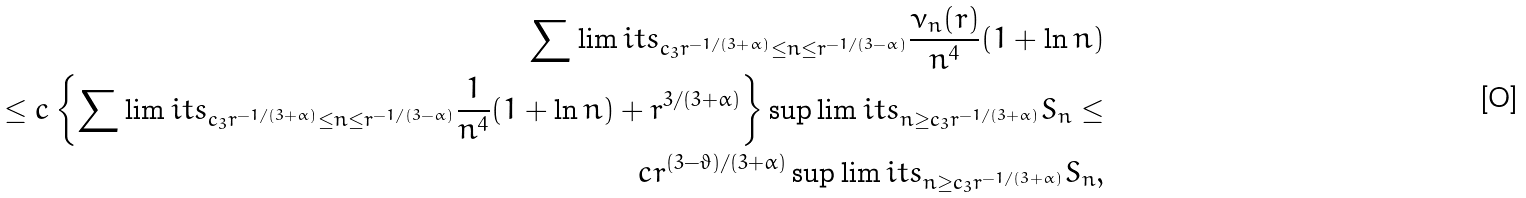Convert formula to latex. <formula><loc_0><loc_0><loc_500><loc_500>\sum \lim i t s _ { c _ { 3 } r ^ { - 1 / ( 3 + \alpha ) } \leq n \leq r ^ { - 1 / ( 3 - \alpha ) } } \frac { \nu _ { n } ( r ) } { n ^ { 4 } } ( 1 + \ln n ) \\ \leq c \left \{ \sum \lim i t s _ { c _ { 3 } r ^ { - 1 / ( 3 + \alpha ) } \leq n \leq r ^ { - 1 / ( 3 - \alpha ) } } \frac { 1 } { n ^ { 4 } } ( 1 + \ln n ) + r ^ { 3 / ( 3 + \alpha ) } \right \} \sup \lim i t s _ { n \geq c _ { 3 } r ^ { - 1 / ( 3 + \alpha ) } } S _ { n } \leq \\ c r ^ { ( 3 - \vartheta ) / ( 3 + \alpha ) } \sup \lim i t s _ { n \geq c _ { 3 } r ^ { - 1 / ( 3 + \alpha ) } } S _ { n } ,</formula> 